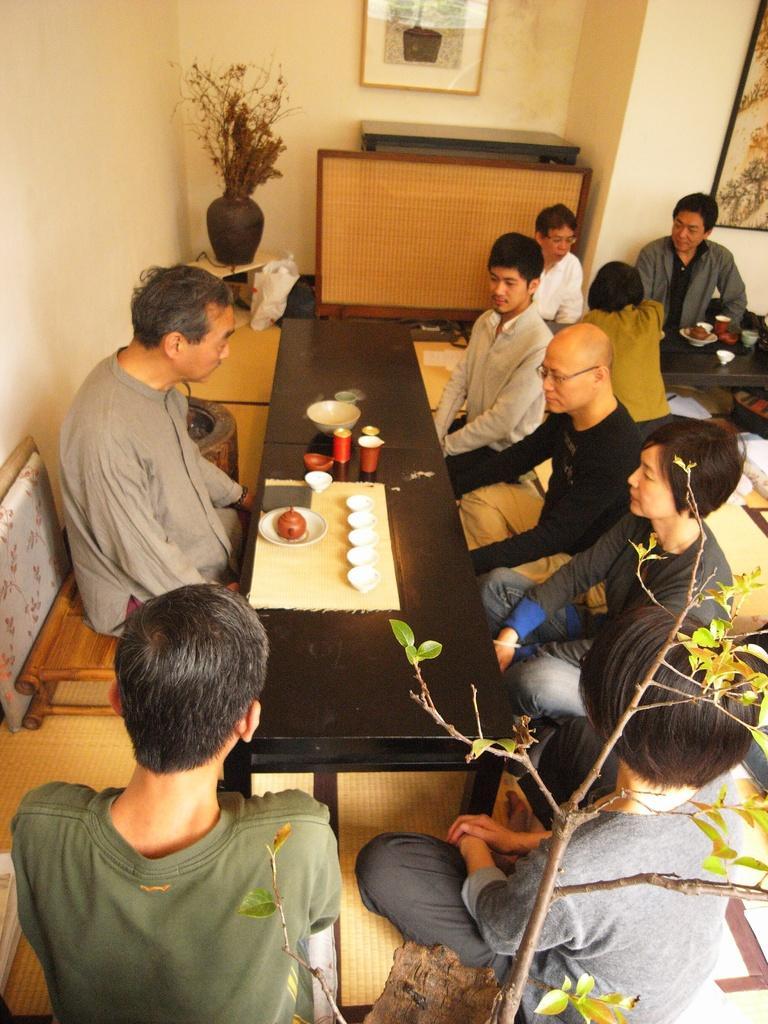Please provide a concise description of this image. In this image I can see the group of people sitting in-front of the table. On the table there is plate,cups and the bowl. There is also a flower vase and the frame attached to the wall. 